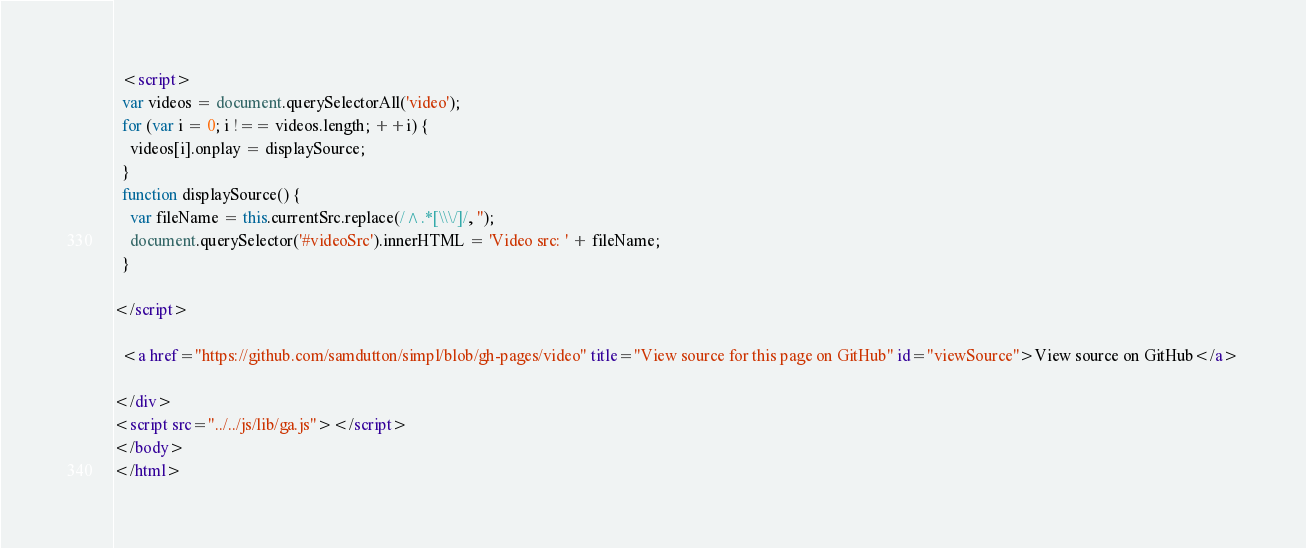Convert code to text. <code><loc_0><loc_0><loc_500><loc_500><_HTML_>  <script>
  var videos = document.querySelectorAll('video');
  for (var i = 0; i !== videos.length; ++i) {
    videos[i].onplay = displaySource;
  }
  function displaySource() {
    var fileName = this.currentSrc.replace(/^.*[\\\/]/, '');
    document.querySelector('#videoSrc').innerHTML = 'Video src: ' + fileName;
  }

</script>

  <a href="https://github.com/samdutton/simpl/blob/gh-pages/video" title="View source for this page on GitHub" id="viewSource">View source on GitHub</a>

</div>
<script src="../../js/lib/ga.js"></script>
</body>
</html>
</code> 